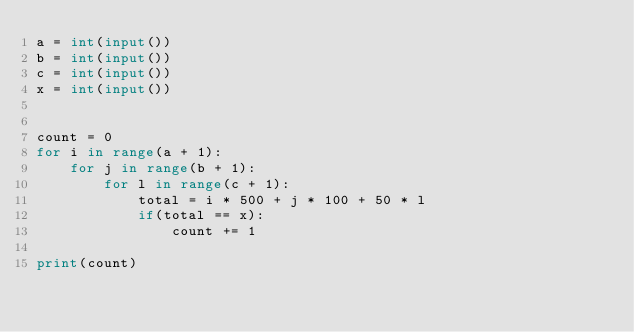Convert code to text. <code><loc_0><loc_0><loc_500><loc_500><_Python_>a = int(input())
b = int(input())
c = int(input())
x = int(input())


count = 0
for i in range(a + 1):
    for j in range(b + 1):
        for l in range(c + 1):
            total = i * 500 + j * 100 + 50 * l
            if(total == x):
                count += 1

print(count)</code> 